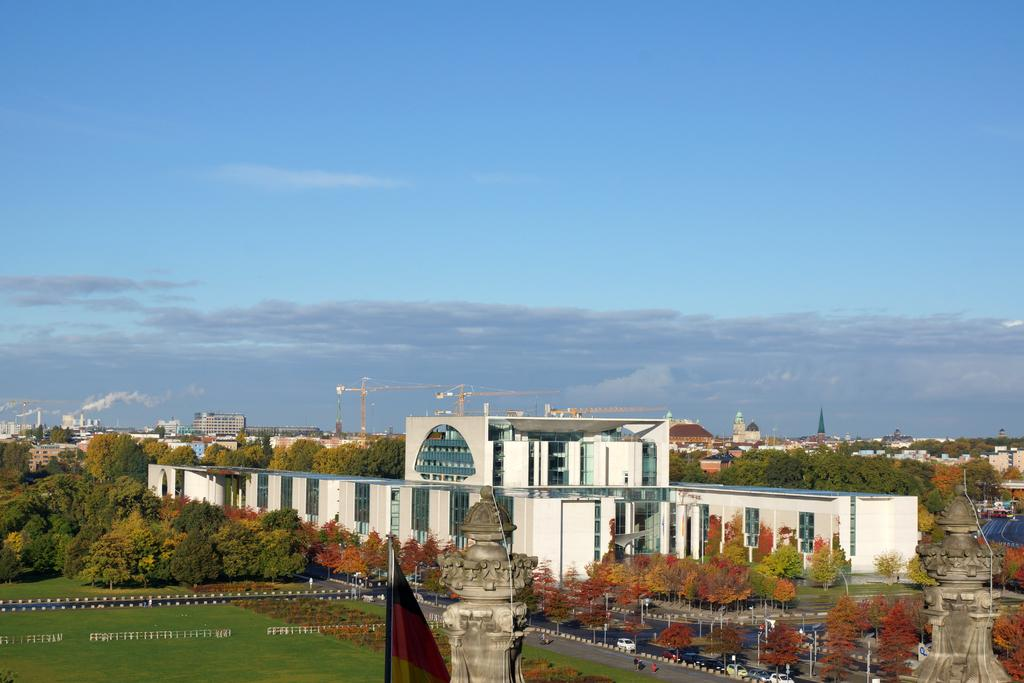What structures are located at the bottom of the image? There are towers, buildings, and trees at the bottom of the image. What else can be seen at the bottom of the image? There are roads at the bottom of the image. What is visible at the top of the image? The sky is visible at the top of the image. Where is the heart-shaped mine located in the image? There is no heart-shaped mine present in the image. Can you tell me how many times the image turns upside down? The image does not turn upside down; it remains stationary. 